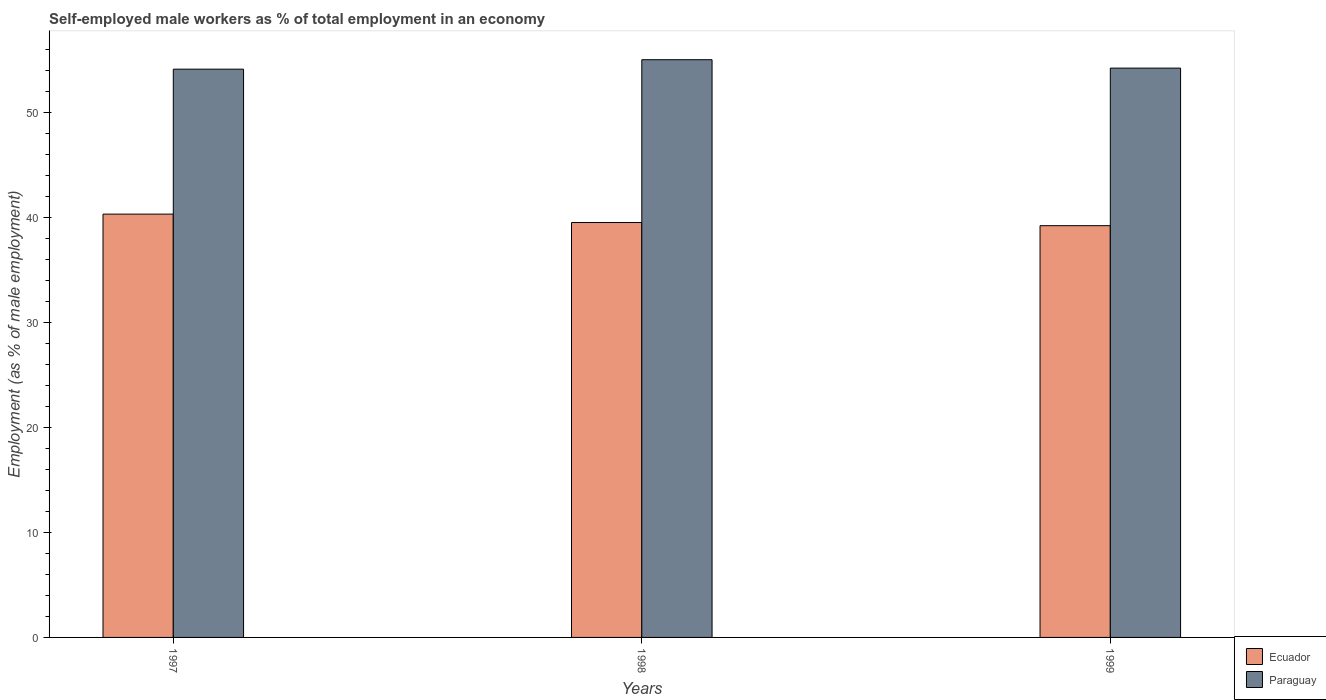How many groups of bars are there?
Ensure brevity in your answer.  3. Are the number of bars on each tick of the X-axis equal?
Ensure brevity in your answer.  Yes. How many bars are there on the 3rd tick from the left?
Give a very brief answer. 2. How many bars are there on the 3rd tick from the right?
Ensure brevity in your answer.  2. What is the label of the 2nd group of bars from the left?
Provide a short and direct response. 1998. What is the percentage of self-employed male workers in Paraguay in 1999?
Your answer should be compact. 54.2. Across all years, what is the minimum percentage of self-employed male workers in Paraguay?
Give a very brief answer. 54.1. In which year was the percentage of self-employed male workers in Ecuador maximum?
Offer a very short reply. 1997. In which year was the percentage of self-employed male workers in Paraguay minimum?
Your answer should be very brief. 1997. What is the total percentage of self-employed male workers in Paraguay in the graph?
Give a very brief answer. 163.3. What is the difference between the percentage of self-employed male workers in Paraguay in 1998 and that in 1999?
Offer a very short reply. 0.8. What is the difference between the percentage of self-employed male workers in Paraguay in 1998 and the percentage of self-employed male workers in Ecuador in 1997?
Your answer should be compact. 14.7. What is the average percentage of self-employed male workers in Paraguay per year?
Keep it short and to the point. 54.43. In the year 1997, what is the difference between the percentage of self-employed male workers in Paraguay and percentage of self-employed male workers in Ecuador?
Your answer should be compact. 13.8. In how many years, is the percentage of self-employed male workers in Ecuador greater than 30 %?
Your answer should be very brief. 3. What is the ratio of the percentage of self-employed male workers in Ecuador in 1997 to that in 1998?
Your answer should be very brief. 1.02. What is the difference between the highest and the second highest percentage of self-employed male workers in Paraguay?
Ensure brevity in your answer.  0.8. What is the difference between the highest and the lowest percentage of self-employed male workers in Paraguay?
Offer a terse response. 0.9. In how many years, is the percentage of self-employed male workers in Ecuador greater than the average percentage of self-employed male workers in Ecuador taken over all years?
Keep it short and to the point. 1. Is the sum of the percentage of self-employed male workers in Paraguay in 1998 and 1999 greater than the maximum percentage of self-employed male workers in Ecuador across all years?
Ensure brevity in your answer.  Yes. What does the 1st bar from the left in 1999 represents?
Provide a succinct answer. Ecuador. What does the 1st bar from the right in 1997 represents?
Provide a short and direct response. Paraguay. How many bars are there?
Offer a very short reply. 6. Does the graph contain any zero values?
Provide a short and direct response. No. Does the graph contain grids?
Your answer should be very brief. No. Where does the legend appear in the graph?
Offer a very short reply. Bottom right. How are the legend labels stacked?
Your response must be concise. Vertical. What is the title of the graph?
Offer a very short reply. Self-employed male workers as % of total employment in an economy. Does "Jamaica" appear as one of the legend labels in the graph?
Provide a short and direct response. No. What is the label or title of the Y-axis?
Your answer should be very brief. Employment (as % of male employment). What is the Employment (as % of male employment) in Ecuador in 1997?
Your answer should be very brief. 40.3. What is the Employment (as % of male employment) in Paraguay in 1997?
Make the answer very short. 54.1. What is the Employment (as % of male employment) in Ecuador in 1998?
Your answer should be very brief. 39.5. What is the Employment (as % of male employment) of Ecuador in 1999?
Your answer should be compact. 39.2. What is the Employment (as % of male employment) of Paraguay in 1999?
Provide a short and direct response. 54.2. Across all years, what is the maximum Employment (as % of male employment) in Ecuador?
Your response must be concise. 40.3. Across all years, what is the minimum Employment (as % of male employment) of Ecuador?
Ensure brevity in your answer.  39.2. Across all years, what is the minimum Employment (as % of male employment) of Paraguay?
Offer a very short reply. 54.1. What is the total Employment (as % of male employment) of Ecuador in the graph?
Your answer should be very brief. 119. What is the total Employment (as % of male employment) of Paraguay in the graph?
Provide a succinct answer. 163.3. What is the difference between the Employment (as % of male employment) of Ecuador in 1998 and that in 1999?
Your response must be concise. 0.3. What is the difference between the Employment (as % of male employment) in Paraguay in 1998 and that in 1999?
Offer a terse response. 0.8. What is the difference between the Employment (as % of male employment) in Ecuador in 1997 and the Employment (as % of male employment) in Paraguay in 1998?
Keep it short and to the point. -14.7. What is the difference between the Employment (as % of male employment) in Ecuador in 1997 and the Employment (as % of male employment) in Paraguay in 1999?
Ensure brevity in your answer.  -13.9. What is the difference between the Employment (as % of male employment) of Ecuador in 1998 and the Employment (as % of male employment) of Paraguay in 1999?
Your answer should be very brief. -14.7. What is the average Employment (as % of male employment) in Ecuador per year?
Your answer should be very brief. 39.67. What is the average Employment (as % of male employment) in Paraguay per year?
Make the answer very short. 54.43. In the year 1997, what is the difference between the Employment (as % of male employment) of Ecuador and Employment (as % of male employment) of Paraguay?
Provide a short and direct response. -13.8. In the year 1998, what is the difference between the Employment (as % of male employment) in Ecuador and Employment (as % of male employment) in Paraguay?
Provide a short and direct response. -15.5. What is the ratio of the Employment (as % of male employment) of Ecuador in 1997 to that in 1998?
Offer a terse response. 1.02. What is the ratio of the Employment (as % of male employment) of Paraguay in 1997 to that in 1998?
Give a very brief answer. 0.98. What is the ratio of the Employment (as % of male employment) of Ecuador in 1997 to that in 1999?
Give a very brief answer. 1.03. What is the ratio of the Employment (as % of male employment) in Ecuador in 1998 to that in 1999?
Offer a terse response. 1.01. What is the ratio of the Employment (as % of male employment) in Paraguay in 1998 to that in 1999?
Offer a terse response. 1.01. What is the difference between the highest and the lowest Employment (as % of male employment) in Ecuador?
Give a very brief answer. 1.1. 